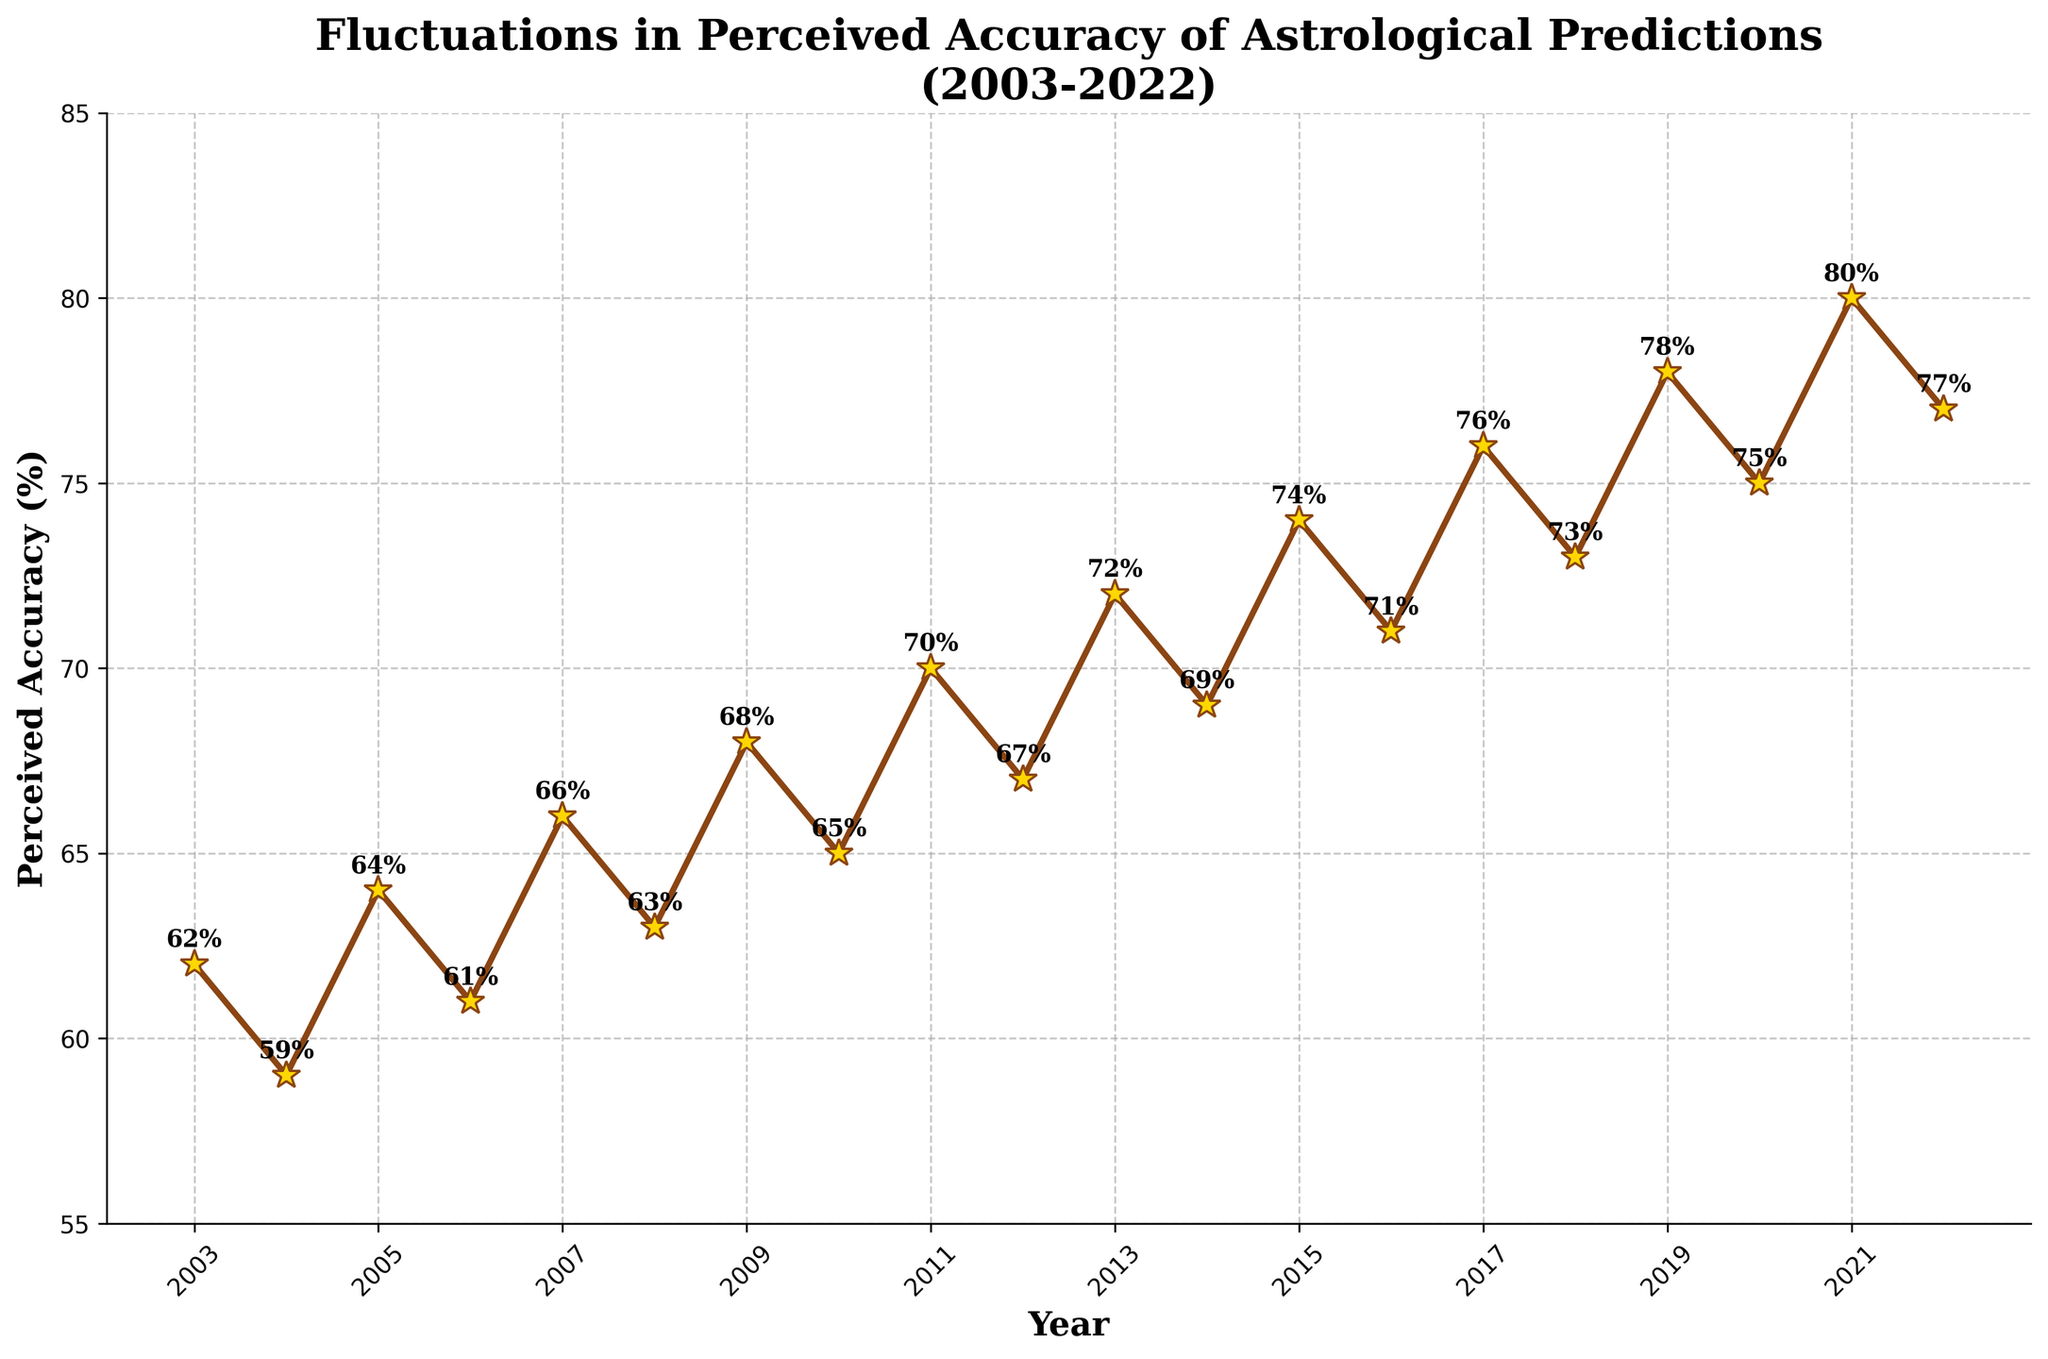When did the perceived accuracy of astrological predictions for crop yields and weather patterns peak? The peak can be identified by looking at the highest point on the line chart. The peak occurs at the data point for the year where the accuracy percentage is the maximum. This happens in 2021 with the highest value recorded.
Answer: 2021 Which year had the lowest perceived accuracy, and what was the percentage? Identify the lowest point on the line chart. This minimum value is observed in the year 2004 with a percentage of 59%.
Answer: 2004 (59%) How much did the perceived accuracy change from 2012 to 2013? The change can be calculated by subtracting the value for 2012 from the value for 2013. For 2012, the percentage is 67%, and for 2013, it’s 72%. Thus, the change is 72% - 67% = 5%.
Answer: 5% What is the average perceived accuracy from 2010 to 2015? To find the average, sum the accuracy percentages from 2010 to 2015 and divide by the number of years. The values are 65%, 70%, 67%, 72%, 69%, and 74%. Average = (65 + 70 + 67 + 72 + 69 + 74) / 6 = 417 / 6 = 69.5%.
Answer: 69.5% Describe the trend in perceived accuracy from 2006 to 2009. From the year 2006 to 2009, the perceived accuracy is increasing. The values are 61%, 66%, 63%, and 68%, respectively. First, it decreases from 2006 to 2007 (61% to 59%) but then increases each year up to 2009 (59% to 64% then to 66%).
Answer: Increasing trend Did the perceived accuracy ever decrease two consecutive years in a row? Examine the line chart for any consecutive dips in accuracy between two years. The perceived accuracy doesn’t decrease consecutively for two years; it fluctuates but never continuously decreases in the dataset provided.
Answer: No Between 2015 and 2020, which year saw the second highest perceived accuracy? The years to consider are 2015, 2016, 2017, 2018, 2019, and 2020. Their corresponding values are 74%, 71%, 76%, 73%, 78%, and 75%. The second highest value is 76%, occurring in 2017.
Answer: 2017 How did the perceived accuracy change from 2003 to 2022? Subtract the 2003 value from the 2022 value. For 2003, it is 62% and for 2022, it’s 77%. Therefore, the change is 77% - 62% = 15%.
Answer: Increased by 15% What is the overall trend in the perceived accuracy from 2003 to 2022? Examine the general direction of the line from start to end. Although there are fluctuations, the overall trend is an increasing one.
Answer: Increasing Which year had exactly 75% perceived accuracy? Look for the year where the line chart shows a value of 75%. The year with 75% perceived accuracy is 2020.
Answer: 2020 